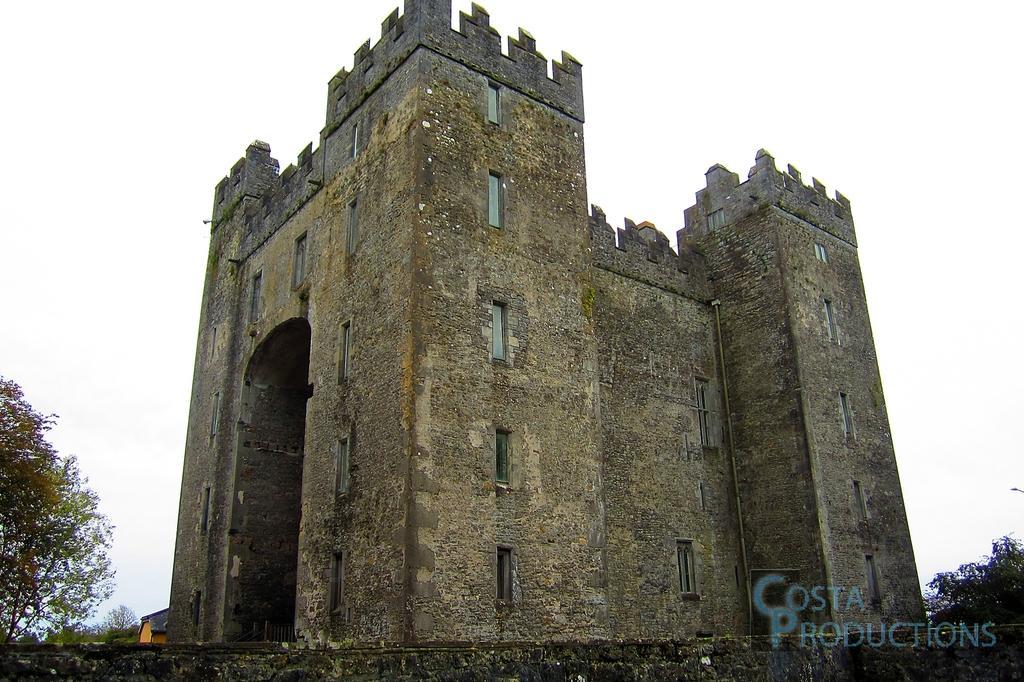Describe this image in one or two sentences. In this picture we can see an old architecture, building and behind the building there are trees and a sky. On the image there is a watermark. 